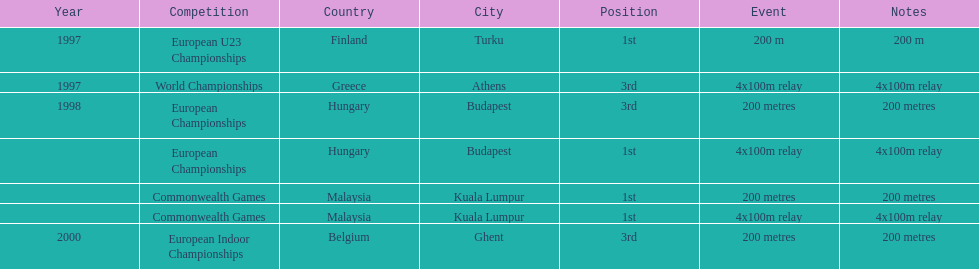How many events were won in malaysia? 2. 